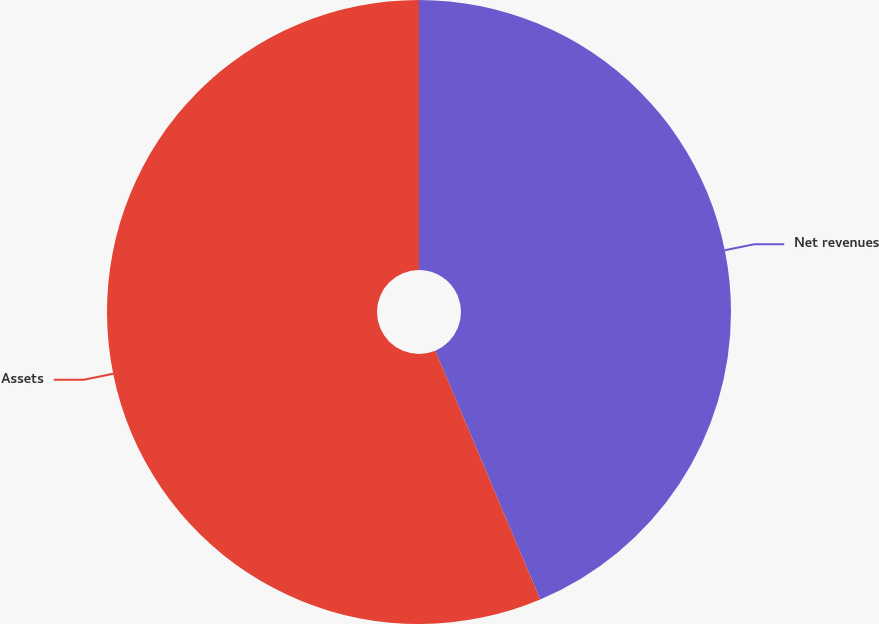Convert chart to OTSL. <chart><loc_0><loc_0><loc_500><loc_500><pie_chart><fcel>Net revenues<fcel>Assets<nl><fcel>43.65%<fcel>56.35%<nl></chart> 